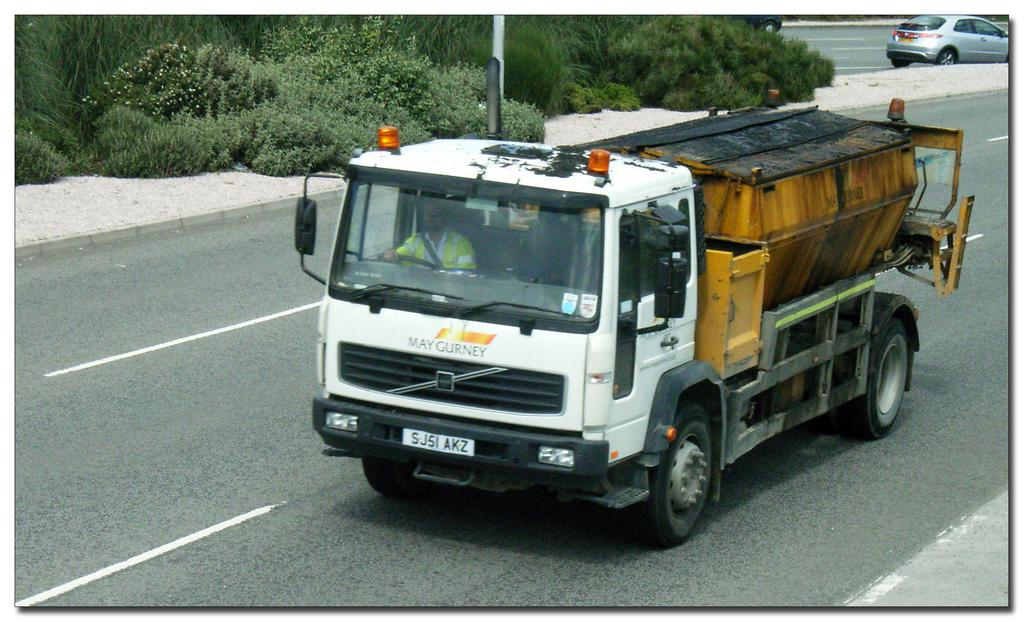What can be seen on the road in the image? There are vehicles on the road in the image. What type of vegetation is on the left side of the image? There are trees on the left side of the image. Where is the crate of cherries located in the image? There is no crate of cherries present in the image. What discovery was made in the image? There is no mention of a discovery in the image. 